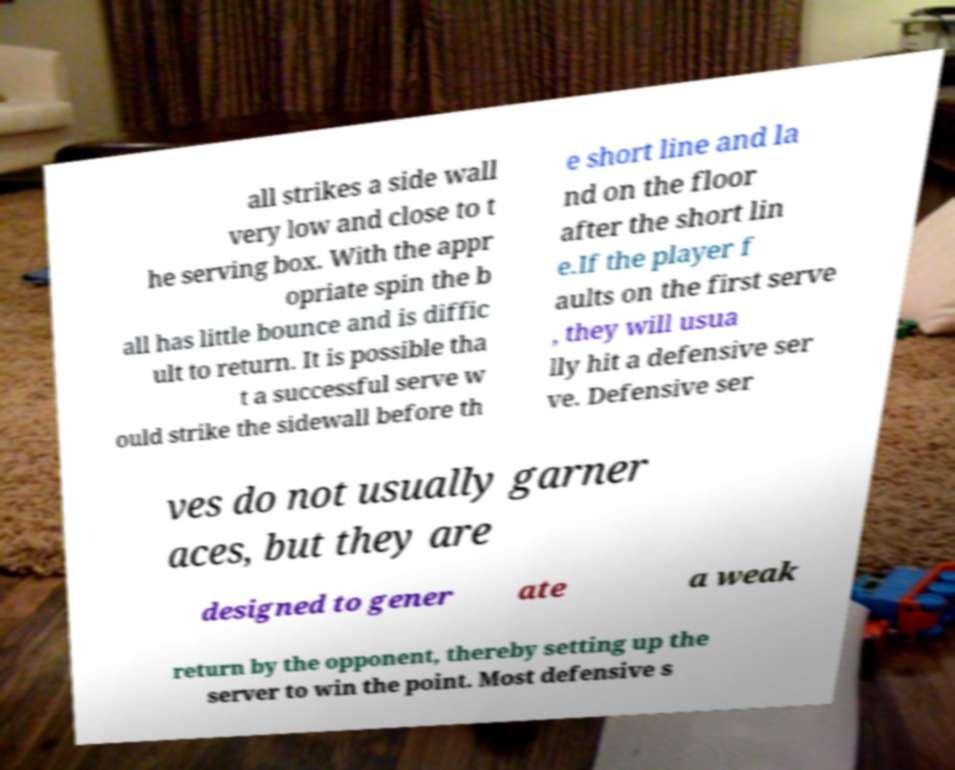What messages or text are displayed in this image? I need them in a readable, typed format. all strikes a side wall very low and close to t he serving box. With the appr opriate spin the b all has little bounce and is diffic ult to return. It is possible tha t a successful serve w ould strike the sidewall before th e short line and la nd on the floor after the short lin e.If the player f aults on the first serve , they will usua lly hit a defensive ser ve. Defensive ser ves do not usually garner aces, but they are designed to gener ate a weak return by the opponent, thereby setting up the server to win the point. Most defensive s 